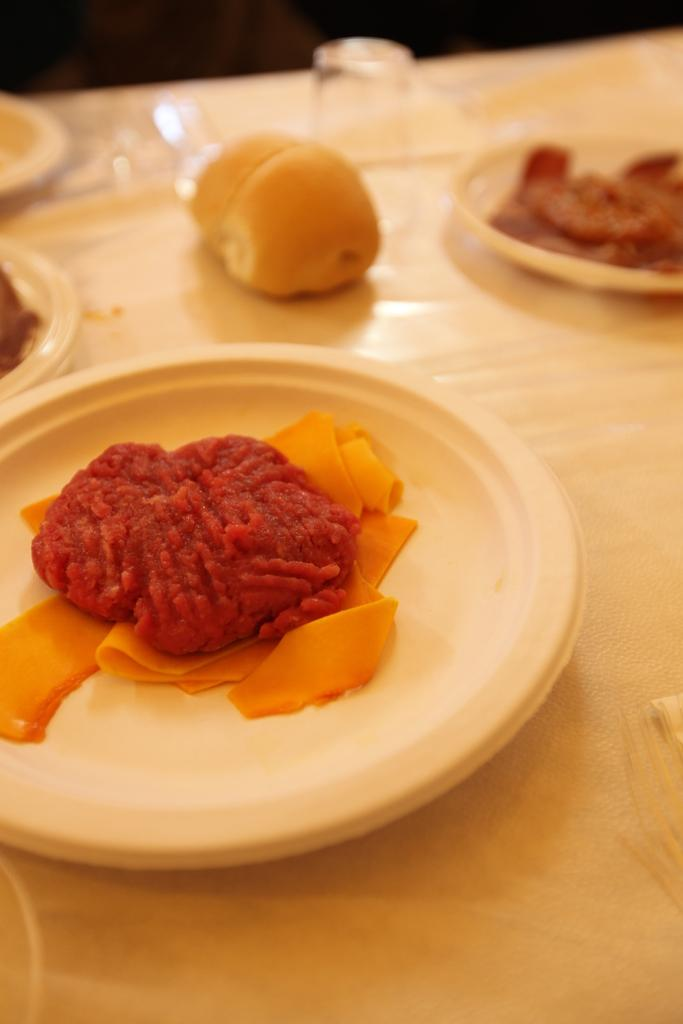What piece of furniture is visible in the image? There is a table in the image. What items are placed on the table? Plates, glasses, and dishes are on the table. Are there any other objects on the table? Yes, there are other objects on the table. What can be seen in the top part of the image? The top part of the image is blurred. What type of action is the curve performing in the image? There is no curve or action present in the image. Can you describe the zipper's location and function in the image? There is no zipper present in the image. 